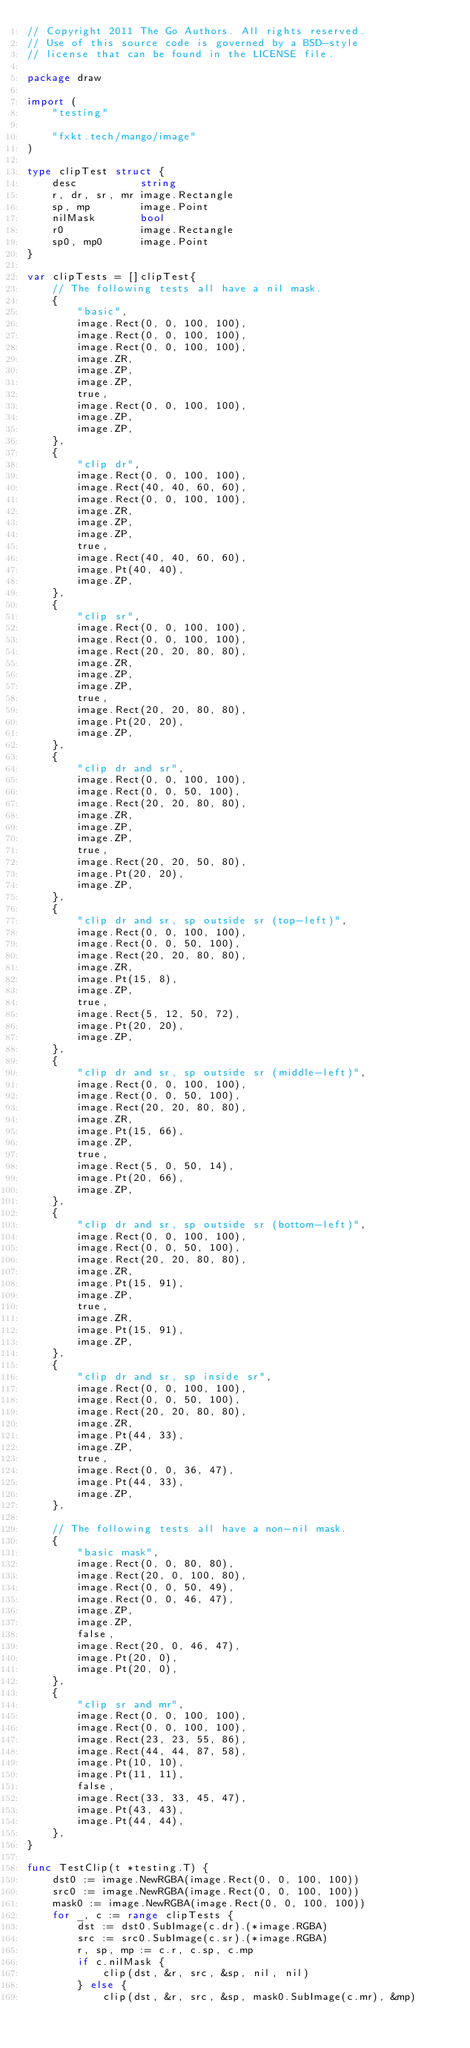Convert code to text. <code><loc_0><loc_0><loc_500><loc_500><_Go_>// Copyright 2011 The Go Authors. All rights reserved.
// Use of this source code is governed by a BSD-style
// license that can be found in the LICENSE file.

package draw

import (
	"testing"

	"fxkt.tech/mango/image"
)

type clipTest struct {
	desc          string
	r, dr, sr, mr image.Rectangle
	sp, mp        image.Point
	nilMask       bool
	r0            image.Rectangle
	sp0, mp0      image.Point
}

var clipTests = []clipTest{
	// The following tests all have a nil mask.
	{
		"basic",
		image.Rect(0, 0, 100, 100),
		image.Rect(0, 0, 100, 100),
		image.Rect(0, 0, 100, 100),
		image.ZR,
		image.ZP,
		image.ZP,
		true,
		image.Rect(0, 0, 100, 100),
		image.ZP,
		image.ZP,
	},
	{
		"clip dr",
		image.Rect(0, 0, 100, 100),
		image.Rect(40, 40, 60, 60),
		image.Rect(0, 0, 100, 100),
		image.ZR,
		image.ZP,
		image.ZP,
		true,
		image.Rect(40, 40, 60, 60),
		image.Pt(40, 40),
		image.ZP,
	},
	{
		"clip sr",
		image.Rect(0, 0, 100, 100),
		image.Rect(0, 0, 100, 100),
		image.Rect(20, 20, 80, 80),
		image.ZR,
		image.ZP,
		image.ZP,
		true,
		image.Rect(20, 20, 80, 80),
		image.Pt(20, 20),
		image.ZP,
	},
	{
		"clip dr and sr",
		image.Rect(0, 0, 100, 100),
		image.Rect(0, 0, 50, 100),
		image.Rect(20, 20, 80, 80),
		image.ZR,
		image.ZP,
		image.ZP,
		true,
		image.Rect(20, 20, 50, 80),
		image.Pt(20, 20),
		image.ZP,
	},
	{
		"clip dr and sr, sp outside sr (top-left)",
		image.Rect(0, 0, 100, 100),
		image.Rect(0, 0, 50, 100),
		image.Rect(20, 20, 80, 80),
		image.ZR,
		image.Pt(15, 8),
		image.ZP,
		true,
		image.Rect(5, 12, 50, 72),
		image.Pt(20, 20),
		image.ZP,
	},
	{
		"clip dr and sr, sp outside sr (middle-left)",
		image.Rect(0, 0, 100, 100),
		image.Rect(0, 0, 50, 100),
		image.Rect(20, 20, 80, 80),
		image.ZR,
		image.Pt(15, 66),
		image.ZP,
		true,
		image.Rect(5, 0, 50, 14),
		image.Pt(20, 66),
		image.ZP,
	},
	{
		"clip dr and sr, sp outside sr (bottom-left)",
		image.Rect(0, 0, 100, 100),
		image.Rect(0, 0, 50, 100),
		image.Rect(20, 20, 80, 80),
		image.ZR,
		image.Pt(15, 91),
		image.ZP,
		true,
		image.ZR,
		image.Pt(15, 91),
		image.ZP,
	},
	{
		"clip dr and sr, sp inside sr",
		image.Rect(0, 0, 100, 100),
		image.Rect(0, 0, 50, 100),
		image.Rect(20, 20, 80, 80),
		image.ZR,
		image.Pt(44, 33),
		image.ZP,
		true,
		image.Rect(0, 0, 36, 47),
		image.Pt(44, 33),
		image.ZP,
	},

	// The following tests all have a non-nil mask.
	{
		"basic mask",
		image.Rect(0, 0, 80, 80),
		image.Rect(20, 0, 100, 80),
		image.Rect(0, 0, 50, 49),
		image.Rect(0, 0, 46, 47),
		image.ZP,
		image.ZP,
		false,
		image.Rect(20, 0, 46, 47),
		image.Pt(20, 0),
		image.Pt(20, 0),
	},
	{
		"clip sr and mr",
		image.Rect(0, 0, 100, 100),
		image.Rect(0, 0, 100, 100),
		image.Rect(23, 23, 55, 86),
		image.Rect(44, 44, 87, 58),
		image.Pt(10, 10),
		image.Pt(11, 11),
		false,
		image.Rect(33, 33, 45, 47),
		image.Pt(43, 43),
		image.Pt(44, 44),
	},
}

func TestClip(t *testing.T) {
	dst0 := image.NewRGBA(image.Rect(0, 0, 100, 100))
	src0 := image.NewRGBA(image.Rect(0, 0, 100, 100))
	mask0 := image.NewRGBA(image.Rect(0, 0, 100, 100))
	for _, c := range clipTests {
		dst := dst0.SubImage(c.dr).(*image.RGBA)
		src := src0.SubImage(c.sr).(*image.RGBA)
		r, sp, mp := c.r, c.sp, c.mp
		if c.nilMask {
			clip(dst, &r, src, &sp, nil, nil)
		} else {
			clip(dst, &r, src, &sp, mask0.SubImage(c.mr), &mp)</code> 